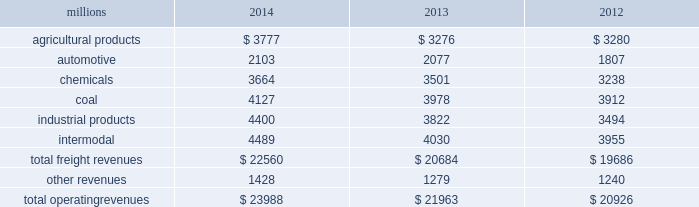Notes to the consolidated financial statements union pacific corporation and subsidiary companies for purposes of this report , unless the context otherwise requires , all references herein to the 201ccorporation 201d , 201ccompany 201d , 201cupc 201d , 201cwe 201d , 201cus 201d , and 201cour 201d mean union pacific corporation and its subsidiaries , including union pacific railroad company , which will be separately referred to herein as 201cuprr 201d or the 201crailroad 201d .
Nature of operations operations and segmentation 2013 we are a class i railroad operating in the u.s .
Our network includes 31974 route miles , linking pacific coast and gulf coast ports with the midwest and eastern u.s .
Gateways and providing several corridors to key mexican gateways .
We own 26012 miles and operate on the remainder pursuant to trackage rights or leases .
We serve the western two-thirds of the country and maintain coordinated schedules with other rail carriers for the handling of freight to and from the atlantic coast , the pacific coast , the southeast , the southwest , canada , and mexico .
Export and import traffic is moved through gulf coast and pacific coast ports and across the mexican and canadian borders .
The railroad , along with its subsidiaries and rail affiliates , is our one reportable operating segment .
Although we provide and review revenue by commodity group , we analyze the net financial results of the railroad as one segment due to the integrated nature of our rail network .
The table provides freight revenue by commodity group : millions 2014 2013 2012 .
Although our revenues are principally derived from customers domiciled in the u.s. , the ultimate points of origination or destination for some products transported by us are outside the u.s .
Each of our commodity groups includes revenue from shipments to and from mexico .
Included in the above table are revenues from our mexico business which amounted to $ 2.3 billion in 2014 , $ 2.1 billion in 2013 , and $ 1.9 billion in 2012 .
Basis of presentation 2013 the consolidated financial statements are presented in accordance with accounting principles generally accepted in the u.s .
( gaap ) as codified in the financial accounting standards board ( fasb ) accounting standards codification ( asc ) .
Significant accounting policies principles of consolidation 2013 the consolidated financial statements include the accounts of union pacific corporation and all of its subsidiaries .
Investments in affiliated companies ( 20% ( 20 % ) to 50% ( 50 % ) owned ) are accounted for using the equity method of accounting .
All intercompany transactions are eliminated .
We currently have no less than majority-owned investments that require consolidation under variable interest entity requirements .
Cash and cash equivalents 2013 cash equivalents consist of investments with original maturities of three months or less .
Accounts receivable 2013 accounts receivable includes receivables reduced by an allowance for doubtful accounts .
The allowance is based upon historical losses , credit worthiness of customers , and current economic conditions .
Receivables not expected to be collected in one year and the associated allowances are classified as other assets in our consolidated statements of financial position. .
What percentage of total freight revenues was the coal commodity group in 2014? 
Computations: (4127 / 23988)
Answer: 0.17204. 